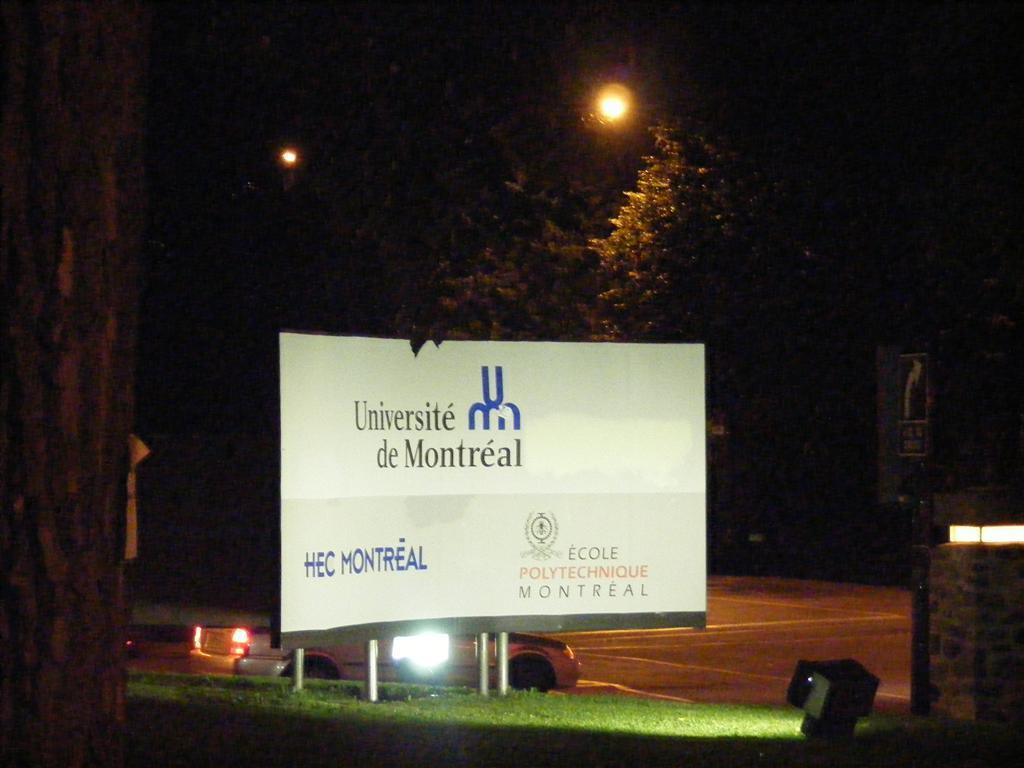<image>
Offer a succinct explanation of the picture presented. The university on the white sign is located in Montreal. 